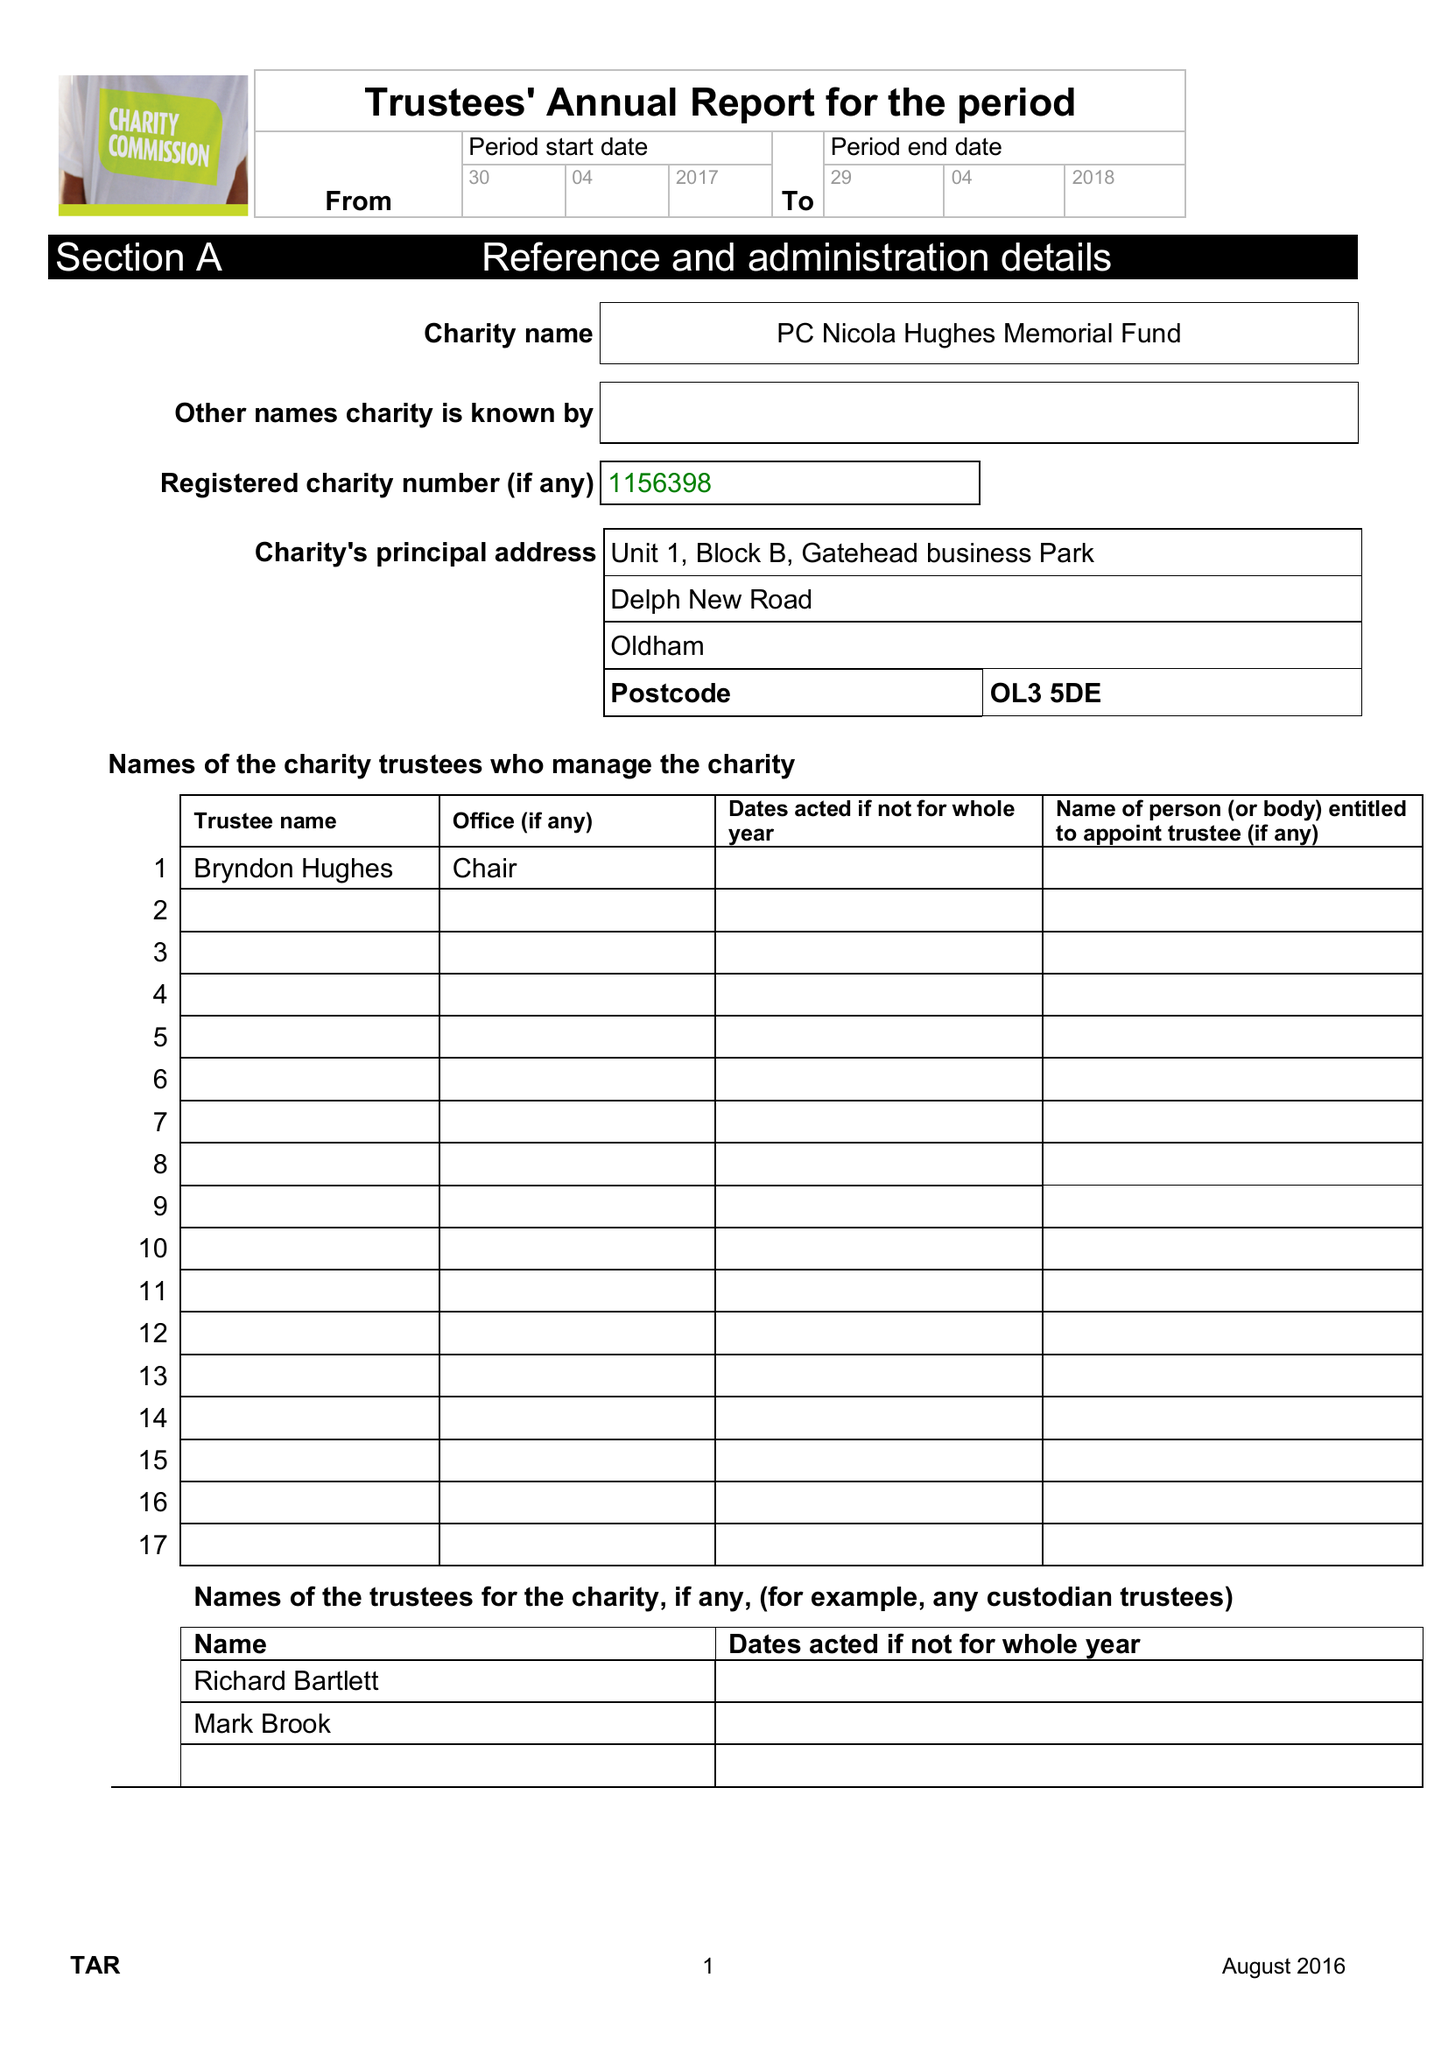What is the value for the charity_name?
Answer the question using a single word or phrase. Pc Nicola Hughes Memorial Fund 